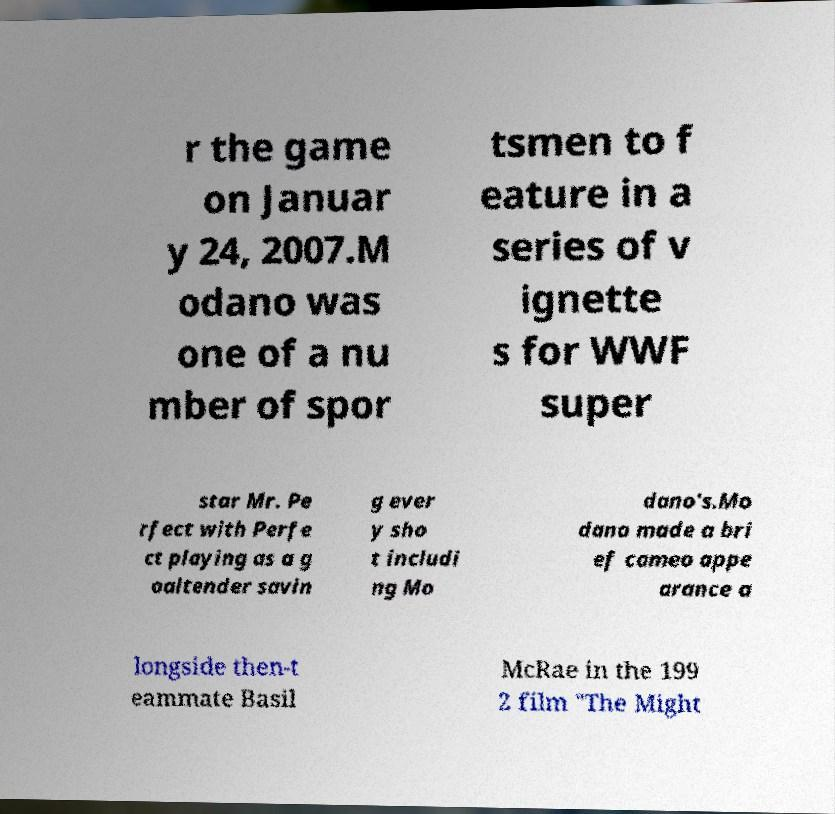Please identify and transcribe the text found in this image. r the game on Januar y 24, 2007.M odano was one of a nu mber of spor tsmen to f eature in a series of v ignette s for WWF super star Mr. Pe rfect with Perfe ct playing as a g oaltender savin g ever y sho t includi ng Mo dano's.Mo dano made a bri ef cameo appe arance a longside then-t eammate Basil McRae in the 199 2 film "The Might 